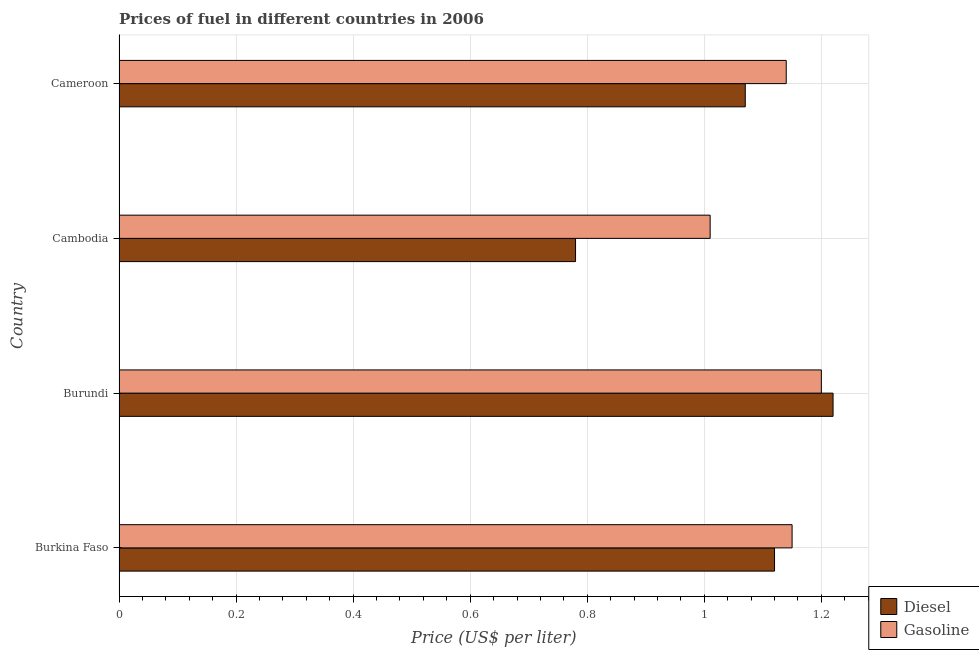How many groups of bars are there?
Provide a succinct answer. 4. Are the number of bars on each tick of the Y-axis equal?
Your response must be concise. Yes. How many bars are there on the 3rd tick from the top?
Make the answer very short. 2. What is the label of the 1st group of bars from the top?
Offer a terse response. Cameroon. What is the gasoline price in Burundi?
Offer a very short reply. 1.2. Across all countries, what is the maximum diesel price?
Provide a succinct answer. 1.22. In which country was the diesel price maximum?
Provide a succinct answer. Burundi. In which country was the gasoline price minimum?
Give a very brief answer. Cambodia. What is the total gasoline price in the graph?
Ensure brevity in your answer.  4.5. What is the difference between the diesel price in Burkina Faso and that in Burundi?
Provide a short and direct response. -0.1. What is the difference between the diesel price in Burundi and the gasoline price in Burkina Faso?
Your response must be concise. 0.07. What is the average diesel price per country?
Give a very brief answer. 1.05. What is the difference between the diesel price and gasoline price in Cameroon?
Your answer should be compact. -0.07. In how many countries, is the diesel price greater than 0.88 US$ per litre?
Keep it short and to the point. 3. What is the ratio of the gasoline price in Burundi to that in Cameroon?
Offer a terse response. 1.05. Is the difference between the gasoline price in Burkina Faso and Cameroon greater than the difference between the diesel price in Burkina Faso and Cameroon?
Your answer should be very brief. No. What is the difference between the highest and the lowest gasoline price?
Ensure brevity in your answer.  0.19. In how many countries, is the diesel price greater than the average diesel price taken over all countries?
Make the answer very short. 3. What does the 2nd bar from the top in Cameroon represents?
Your answer should be very brief. Diesel. What does the 1st bar from the bottom in Cambodia represents?
Your answer should be very brief. Diesel. Are all the bars in the graph horizontal?
Keep it short and to the point. Yes. How many countries are there in the graph?
Make the answer very short. 4. What is the difference between two consecutive major ticks on the X-axis?
Your response must be concise. 0.2. Are the values on the major ticks of X-axis written in scientific E-notation?
Keep it short and to the point. No. Does the graph contain any zero values?
Offer a very short reply. No. How are the legend labels stacked?
Provide a succinct answer. Vertical. What is the title of the graph?
Give a very brief answer. Prices of fuel in different countries in 2006. What is the label or title of the X-axis?
Keep it short and to the point. Price (US$ per liter). What is the label or title of the Y-axis?
Your response must be concise. Country. What is the Price (US$ per liter) of Diesel in Burkina Faso?
Offer a terse response. 1.12. What is the Price (US$ per liter) of Gasoline in Burkina Faso?
Provide a succinct answer. 1.15. What is the Price (US$ per liter) of Diesel in Burundi?
Your answer should be very brief. 1.22. What is the Price (US$ per liter) of Diesel in Cambodia?
Provide a short and direct response. 0.78. What is the Price (US$ per liter) of Diesel in Cameroon?
Your response must be concise. 1.07. What is the Price (US$ per liter) of Gasoline in Cameroon?
Provide a succinct answer. 1.14. Across all countries, what is the maximum Price (US$ per liter) in Diesel?
Ensure brevity in your answer.  1.22. Across all countries, what is the minimum Price (US$ per liter) of Diesel?
Offer a very short reply. 0.78. Across all countries, what is the minimum Price (US$ per liter) of Gasoline?
Your answer should be compact. 1.01. What is the total Price (US$ per liter) in Diesel in the graph?
Provide a succinct answer. 4.19. What is the difference between the Price (US$ per liter) in Diesel in Burkina Faso and that in Burundi?
Your response must be concise. -0.1. What is the difference between the Price (US$ per liter) in Gasoline in Burkina Faso and that in Burundi?
Make the answer very short. -0.05. What is the difference between the Price (US$ per liter) of Diesel in Burkina Faso and that in Cambodia?
Offer a very short reply. 0.34. What is the difference between the Price (US$ per liter) in Gasoline in Burkina Faso and that in Cambodia?
Your answer should be compact. 0.14. What is the difference between the Price (US$ per liter) of Diesel in Burundi and that in Cambodia?
Ensure brevity in your answer.  0.44. What is the difference between the Price (US$ per liter) in Gasoline in Burundi and that in Cambodia?
Provide a succinct answer. 0.19. What is the difference between the Price (US$ per liter) in Diesel in Cambodia and that in Cameroon?
Give a very brief answer. -0.29. What is the difference between the Price (US$ per liter) of Gasoline in Cambodia and that in Cameroon?
Offer a terse response. -0.13. What is the difference between the Price (US$ per liter) of Diesel in Burkina Faso and the Price (US$ per liter) of Gasoline in Burundi?
Give a very brief answer. -0.08. What is the difference between the Price (US$ per liter) in Diesel in Burkina Faso and the Price (US$ per liter) in Gasoline in Cambodia?
Provide a succinct answer. 0.11. What is the difference between the Price (US$ per liter) of Diesel in Burkina Faso and the Price (US$ per liter) of Gasoline in Cameroon?
Ensure brevity in your answer.  -0.02. What is the difference between the Price (US$ per liter) in Diesel in Burundi and the Price (US$ per liter) in Gasoline in Cambodia?
Keep it short and to the point. 0.21. What is the difference between the Price (US$ per liter) of Diesel in Burundi and the Price (US$ per liter) of Gasoline in Cameroon?
Ensure brevity in your answer.  0.08. What is the difference between the Price (US$ per liter) in Diesel in Cambodia and the Price (US$ per liter) in Gasoline in Cameroon?
Provide a succinct answer. -0.36. What is the average Price (US$ per liter) of Diesel per country?
Your response must be concise. 1.05. What is the difference between the Price (US$ per liter) of Diesel and Price (US$ per liter) of Gasoline in Burkina Faso?
Your response must be concise. -0.03. What is the difference between the Price (US$ per liter) of Diesel and Price (US$ per liter) of Gasoline in Cambodia?
Ensure brevity in your answer.  -0.23. What is the difference between the Price (US$ per liter) of Diesel and Price (US$ per liter) of Gasoline in Cameroon?
Make the answer very short. -0.07. What is the ratio of the Price (US$ per liter) in Diesel in Burkina Faso to that in Burundi?
Make the answer very short. 0.92. What is the ratio of the Price (US$ per liter) in Gasoline in Burkina Faso to that in Burundi?
Make the answer very short. 0.96. What is the ratio of the Price (US$ per liter) of Diesel in Burkina Faso to that in Cambodia?
Give a very brief answer. 1.44. What is the ratio of the Price (US$ per liter) in Gasoline in Burkina Faso to that in Cambodia?
Ensure brevity in your answer.  1.14. What is the ratio of the Price (US$ per liter) of Diesel in Burkina Faso to that in Cameroon?
Provide a succinct answer. 1.05. What is the ratio of the Price (US$ per liter) in Gasoline in Burkina Faso to that in Cameroon?
Provide a short and direct response. 1.01. What is the ratio of the Price (US$ per liter) in Diesel in Burundi to that in Cambodia?
Your response must be concise. 1.56. What is the ratio of the Price (US$ per liter) of Gasoline in Burundi to that in Cambodia?
Keep it short and to the point. 1.19. What is the ratio of the Price (US$ per liter) in Diesel in Burundi to that in Cameroon?
Provide a short and direct response. 1.14. What is the ratio of the Price (US$ per liter) in Gasoline in Burundi to that in Cameroon?
Offer a very short reply. 1.05. What is the ratio of the Price (US$ per liter) in Diesel in Cambodia to that in Cameroon?
Make the answer very short. 0.73. What is the ratio of the Price (US$ per liter) of Gasoline in Cambodia to that in Cameroon?
Your answer should be compact. 0.89. What is the difference between the highest and the second highest Price (US$ per liter) in Gasoline?
Offer a very short reply. 0.05. What is the difference between the highest and the lowest Price (US$ per liter) of Diesel?
Offer a very short reply. 0.44. What is the difference between the highest and the lowest Price (US$ per liter) in Gasoline?
Make the answer very short. 0.19. 